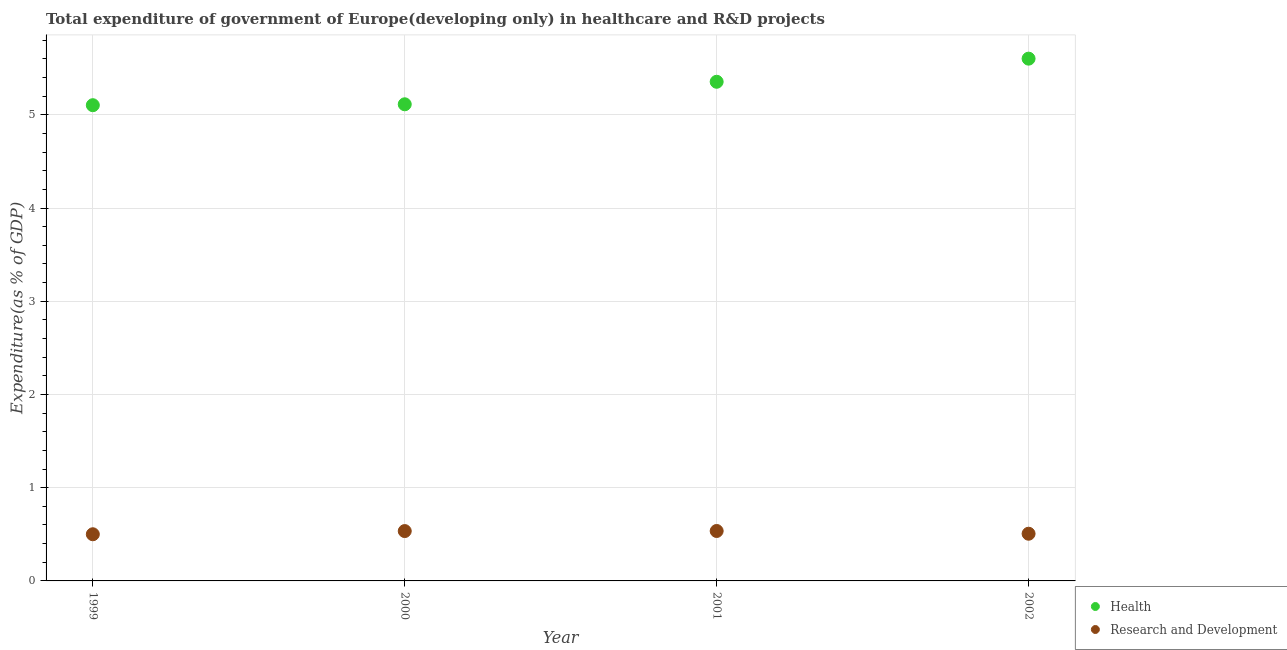Is the number of dotlines equal to the number of legend labels?
Give a very brief answer. Yes. What is the expenditure in r&d in 2002?
Provide a succinct answer. 0.51. Across all years, what is the maximum expenditure in r&d?
Your answer should be compact. 0.54. Across all years, what is the minimum expenditure in healthcare?
Offer a very short reply. 5.1. In which year was the expenditure in r&d minimum?
Your response must be concise. 1999. What is the total expenditure in r&d in the graph?
Your answer should be compact. 2.08. What is the difference between the expenditure in healthcare in 2000 and that in 2002?
Make the answer very short. -0.49. What is the difference between the expenditure in r&d in 2001 and the expenditure in healthcare in 2002?
Your answer should be very brief. -5.07. What is the average expenditure in r&d per year?
Provide a succinct answer. 0.52. In the year 2001, what is the difference between the expenditure in healthcare and expenditure in r&d?
Keep it short and to the point. 4.82. In how many years, is the expenditure in healthcare greater than 0.8 %?
Make the answer very short. 4. What is the ratio of the expenditure in healthcare in 1999 to that in 2002?
Ensure brevity in your answer.  0.91. What is the difference between the highest and the second highest expenditure in r&d?
Your response must be concise. 0. What is the difference between the highest and the lowest expenditure in healthcare?
Your answer should be compact. 0.5. In how many years, is the expenditure in r&d greater than the average expenditure in r&d taken over all years?
Your response must be concise. 2. Is the expenditure in r&d strictly greater than the expenditure in healthcare over the years?
Provide a succinct answer. No. How many years are there in the graph?
Your answer should be very brief. 4. Are the values on the major ticks of Y-axis written in scientific E-notation?
Make the answer very short. No. What is the title of the graph?
Provide a succinct answer. Total expenditure of government of Europe(developing only) in healthcare and R&D projects. What is the label or title of the Y-axis?
Give a very brief answer. Expenditure(as % of GDP). What is the Expenditure(as % of GDP) of Health in 1999?
Your answer should be very brief. 5.1. What is the Expenditure(as % of GDP) of Research and Development in 1999?
Offer a very short reply. 0.5. What is the Expenditure(as % of GDP) of Health in 2000?
Keep it short and to the point. 5.11. What is the Expenditure(as % of GDP) of Research and Development in 2000?
Give a very brief answer. 0.53. What is the Expenditure(as % of GDP) of Health in 2001?
Provide a short and direct response. 5.35. What is the Expenditure(as % of GDP) in Research and Development in 2001?
Ensure brevity in your answer.  0.54. What is the Expenditure(as % of GDP) of Health in 2002?
Your answer should be compact. 5.6. What is the Expenditure(as % of GDP) in Research and Development in 2002?
Offer a terse response. 0.51. Across all years, what is the maximum Expenditure(as % of GDP) of Health?
Keep it short and to the point. 5.6. Across all years, what is the maximum Expenditure(as % of GDP) of Research and Development?
Offer a terse response. 0.54. Across all years, what is the minimum Expenditure(as % of GDP) in Health?
Your answer should be very brief. 5.1. Across all years, what is the minimum Expenditure(as % of GDP) of Research and Development?
Provide a succinct answer. 0.5. What is the total Expenditure(as % of GDP) in Health in the graph?
Offer a very short reply. 21.17. What is the total Expenditure(as % of GDP) in Research and Development in the graph?
Provide a short and direct response. 2.08. What is the difference between the Expenditure(as % of GDP) of Health in 1999 and that in 2000?
Your response must be concise. -0.01. What is the difference between the Expenditure(as % of GDP) of Research and Development in 1999 and that in 2000?
Ensure brevity in your answer.  -0.03. What is the difference between the Expenditure(as % of GDP) of Health in 1999 and that in 2001?
Provide a succinct answer. -0.25. What is the difference between the Expenditure(as % of GDP) of Research and Development in 1999 and that in 2001?
Your response must be concise. -0.04. What is the difference between the Expenditure(as % of GDP) of Health in 1999 and that in 2002?
Ensure brevity in your answer.  -0.5. What is the difference between the Expenditure(as % of GDP) of Research and Development in 1999 and that in 2002?
Your answer should be compact. -0.01. What is the difference between the Expenditure(as % of GDP) in Health in 2000 and that in 2001?
Your response must be concise. -0.24. What is the difference between the Expenditure(as % of GDP) of Research and Development in 2000 and that in 2001?
Your answer should be very brief. -0. What is the difference between the Expenditure(as % of GDP) in Health in 2000 and that in 2002?
Your answer should be compact. -0.49. What is the difference between the Expenditure(as % of GDP) in Research and Development in 2000 and that in 2002?
Give a very brief answer. 0.03. What is the difference between the Expenditure(as % of GDP) of Health in 2001 and that in 2002?
Provide a short and direct response. -0.25. What is the difference between the Expenditure(as % of GDP) of Research and Development in 2001 and that in 2002?
Give a very brief answer. 0.03. What is the difference between the Expenditure(as % of GDP) in Health in 1999 and the Expenditure(as % of GDP) in Research and Development in 2000?
Make the answer very short. 4.57. What is the difference between the Expenditure(as % of GDP) of Health in 1999 and the Expenditure(as % of GDP) of Research and Development in 2001?
Offer a terse response. 4.57. What is the difference between the Expenditure(as % of GDP) in Health in 1999 and the Expenditure(as % of GDP) in Research and Development in 2002?
Ensure brevity in your answer.  4.6. What is the difference between the Expenditure(as % of GDP) in Health in 2000 and the Expenditure(as % of GDP) in Research and Development in 2001?
Give a very brief answer. 4.58. What is the difference between the Expenditure(as % of GDP) of Health in 2000 and the Expenditure(as % of GDP) of Research and Development in 2002?
Ensure brevity in your answer.  4.61. What is the difference between the Expenditure(as % of GDP) of Health in 2001 and the Expenditure(as % of GDP) of Research and Development in 2002?
Provide a short and direct response. 4.85. What is the average Expenditure(as % of GDP) of Health per year?
Ensure brevity in your answer.  5.29. What is the average Expenditure(as % of GDP) in Research and Development per year?
Your response must be concise. 0.52. In the year 1999, what is the difference between the Expenditure(as % of GDP) of Health and Expenditure(as % of GDP) of Research and Development?
Make the answer very short. 4.6. In the year 2000, what is the difference between the Expenditure(as % of GDP) of Health and Expenditure(as % of GDP) of Research and Development?
Give a very brief answer. 4.58. In the year 2001, what is the difference between the Expenditure(as % of GDP) of Health and Expenditure(as % of GDP) of Research and Development?
Provide a short and direct response. 4.82. In the year 2002, what is the difference between the Expenditure(as % of GDP) in Health and Expenditure(as % of GDP) in Research and Development?
Make the answer very short. 5.1. What is the ratio of the Expenditure(as % of GDP) of Health in 1999 to that in 2000?
Your answer should be compact. 1. What is the ratio of the Expenditure(as % of GDP) of Research and Development in 1999 to that in 2000?
Give a very brief answer. 0.94. What is the ratio of the Expenditure(as % of GDP) in Health in 1999 to that in 2001?
Your answer should be very brief. 0.95. What is the ratio of the Expenditure(as % of GDP) of Research and Development in 1999 to that in 2001?
Ensure brevity in your answer.  0.93. What is the ratio of the Expenditure(as % of GDP) in Health in 1999 to that in 2002?
Offer a terse response. 0.91. What is the ratio of the Expenditure(as % of GDP) of Health in 2000 to that in 2001?
Your response must be concise. 0.95. What is the ratio of the Expenditure(as % of GDP) of Research and Development in 2000 to that in 2001?
Provide a short and direct response. 1. What is the ratio of the Expenditure(as % of GDP) in Health in 2000 to that in 2002?
Make the answer very short. 0.91. What is the ratio of the Expenditure(as % of GDP) of Research and Development in 2000 to that in 2002?
Your answer should be very brief. 1.06. What is the ratio of the Expenditure(as % of GDP) of Health in 2001 to that in 2002?
Ensure brevity in your answer.  0.96. What is the ratio of the Expenditure(as % of GDP) of Research and Development in 2001 to that in 2002?
Your answer should be compact. 1.06. What is the difference between the highest and the second highest Expenditure(as % of GDP) of Health?
Your answer should be compact. 0.25. What is the difference between the highest and the second highest Expenditure(as % of GDP) in Research and Development?
Keep it short and to the point. 0. What is the difference between the highest and the lowest Expenditure(as % of GDP) in Health?
Offer a very short reply. 0.5. What is the difference between the highest and the lowest Expenditure(as % of GDP) of Research and Development?
Offer a very short reply. 0.04. 